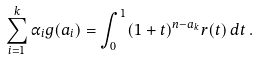Convert formula to latex. <formula><loc_0><loc_0><loc_500><loc_500>\sum _ { i = 1 } ^ { k } \alpha _ { i } g ( a _ { i } ) = \int _ { 0 } ^ { 1 } ( 1 + t ) ^ { n - a _ { k } } r ( t ) \, d t \, .</formula> 